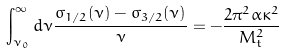<formula> <loc_0><loc_0><loc_500><loc_500>\int _ { \nu _ { 0 } } ^ { \infty } d \nu \frac { \sigma _ { 1 / 2 } ( \nu ) - \sigma _ { 3 / 2 } ( \nu ) } { \nu } = - \frac { 2 \pi ^ { 2 } \alpha \kappa ^ { 2 } } { M _ { t } ^ { 2 } }</formula> 